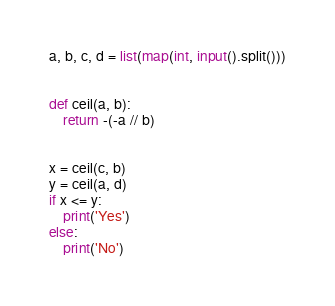<code> <loc_0><loc_0><loc_500><loc_500><_Python_>a, b, c, d = list(map(int, input().split()))


def ceil(a, b):
    return -(-a // b)


x = ceil(c, b)
y = ceil(a, d)
if x <= y:
    print('Yes')
else:
    print('No')
</code> 